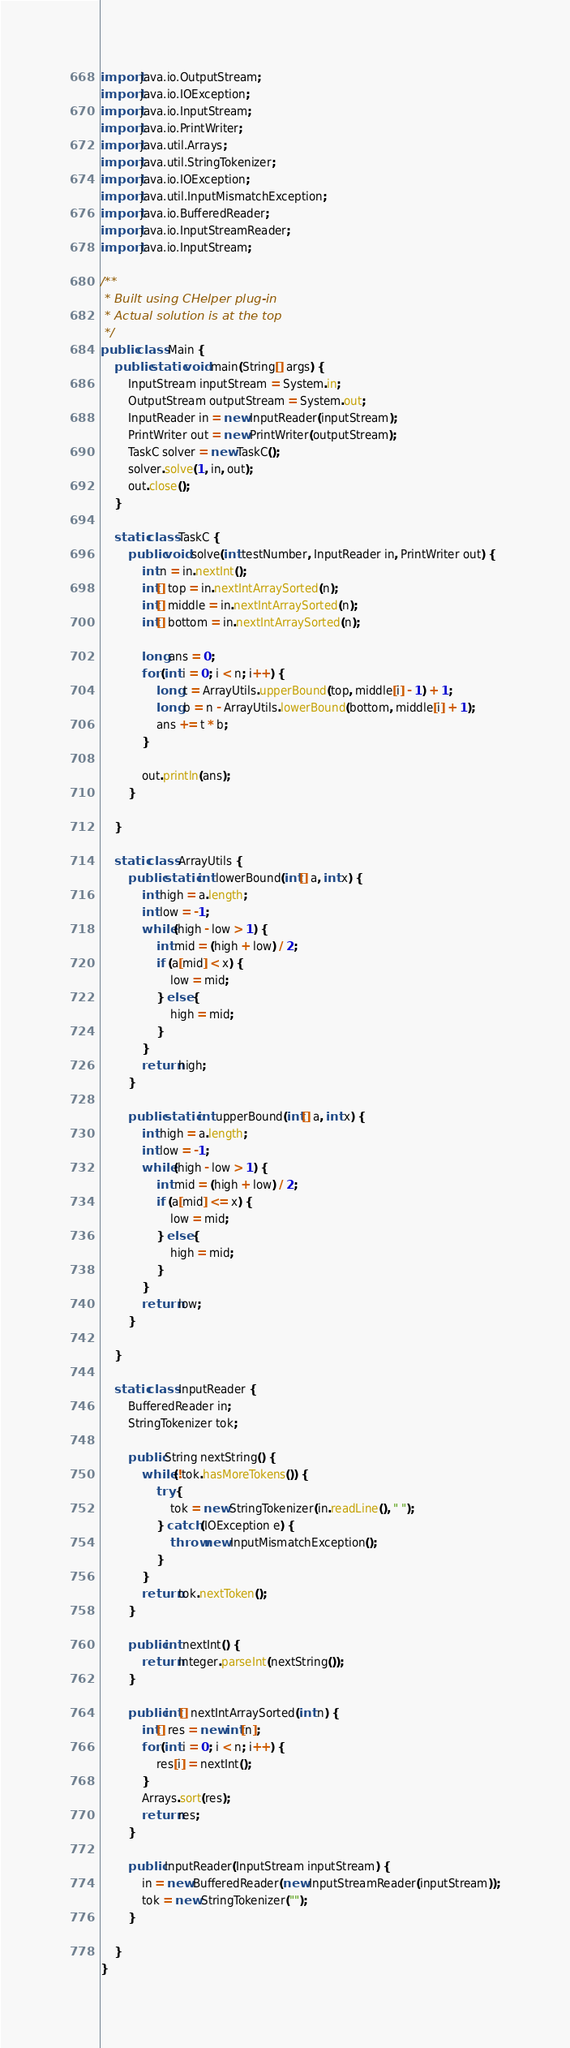Convert code to text. <code><loc_0><loc_0><loc_500><loc_500><_Java_>import java.io.OutputStream;
import java.io.IOException;
import java.io.InputStream;
import java.io.PrintWriter;
import java.util.Arrays;
import java.util.StringTokenizer;
import java.io.IOException;
import java.util.InputMismatchException;
import java.io.BufferedReader;
import java.io.InputStreamReader;
import java.io.InputStream;

/**
 * Built using CHelper plug-in
 * Actual solution is at the top
 */
public class Main {
    public static void main(String[] args) {
        InputStream inputStream = System.in;
        OutputStream outputStream = System.out;
        InputReader in = new InputReader(inputStream);
        PrintWriter out = new PrintWriter(outputStream);
        TaskC solver = new TaskC();
        solver.solve(1, in, out);
        out.close();
    }

    static class TaskC {
        public void solve(int testNumber, InputReader in, PrintWriter out) {
            int n = in.nextInt();
            int[] top = in.nextIntArraySorted(n);
            int[] middle = in.nextIntArraySorted(n);
            int[] bottom = in.nextIntArraySorted(n);

            long ans = 0;
            for (int i = 0; i < n; i++) {
                long t = ArrayUtils.upperBound(top, middle[i] - 1) + 1;
                long b = n - ArrayUtils.lowerBound(bottom, middle[i] + 1);
                ans += t * b;
            }

            out.println(ans);
        }

    }

    static class ArrayUtils {
        public static int lowerBound(int[] a, int x) {
            int high = a.length;
            int low = -1;
            while (high - low > 1) {
                int mid = (high + low) / 2;
                if (a[mid] < x) {
                    low = mid;
                } else {
                    high = mid;
                }
            }
            return high;
        }

        public static int upperBound(int[] a, int x) {
            int high = a.length;
            int low = -1;
            while (high - low > 1) {
                int mid = (high + low) / 2;
                if (a[mid] <= x) {
                    low = mid;
                } else {
                    high = mid;
                }
            }
            return low;
        }

    }

    static class InputReader {
        BufferedReader in;
        StringTokenizer tok;

        public String nextString() {
            while (!tok.hasMoreTokens()) {
                try {
                    tok = new StringTokenizer(in.readLine(), " ");
                } catch (IOException e) {
                    throw new InputMismatchException();
                }
            }
            return tok.nextToken();
        }

        public int nextInt() {
            return Integer.parseInt(nextString());
        }

        public int[] nextIntArraySorted(int n) {
            int[] res = new int[n];
            for (int i = 0; i < n; i++) {
                res[i] = nextInt();
            }
            Arrays.sort(res);
            return res;
        }

        public InputReader(InputStream inputStream) {
            in = new BufferedReader(new InputStreamReader(inputStream));
            tok = new StringTokenizer("");
        }

    }
}

</code> 